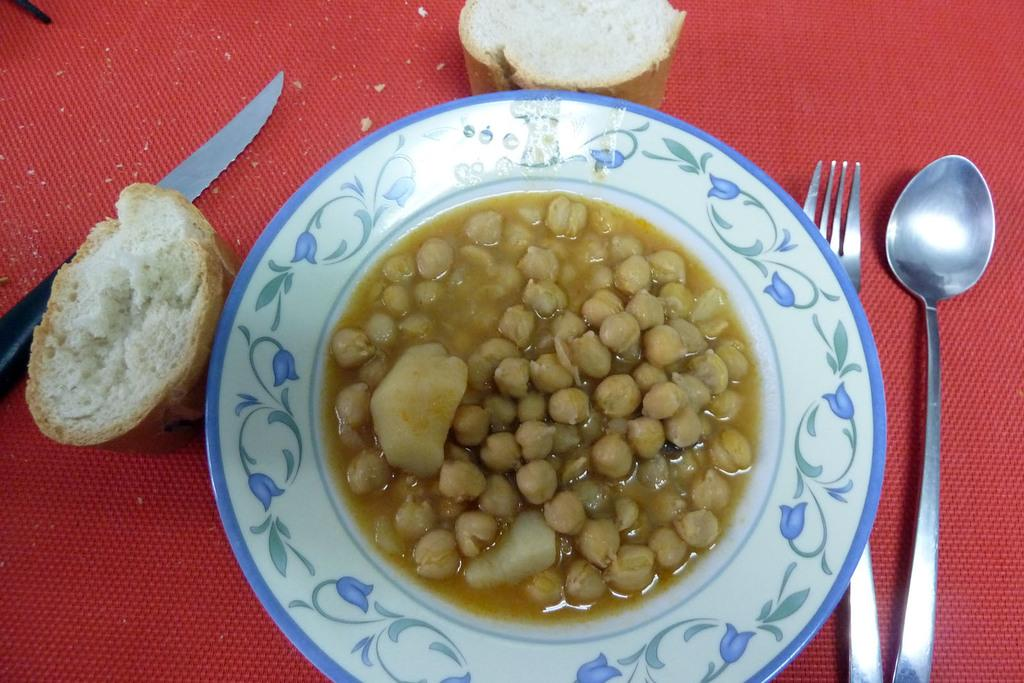What is in the center of the image? There is a plate in the center of the image. What is on the plate? The plate contains food. What utensils are beside the plate? There is a spoon, a fork, and a knife beside the plate. What type of food accompanies the plate in the image? There are buns beside the plate. What type of meal is being shared between the couple in the image? There is no couple present in the image, and no meal is being shared. 